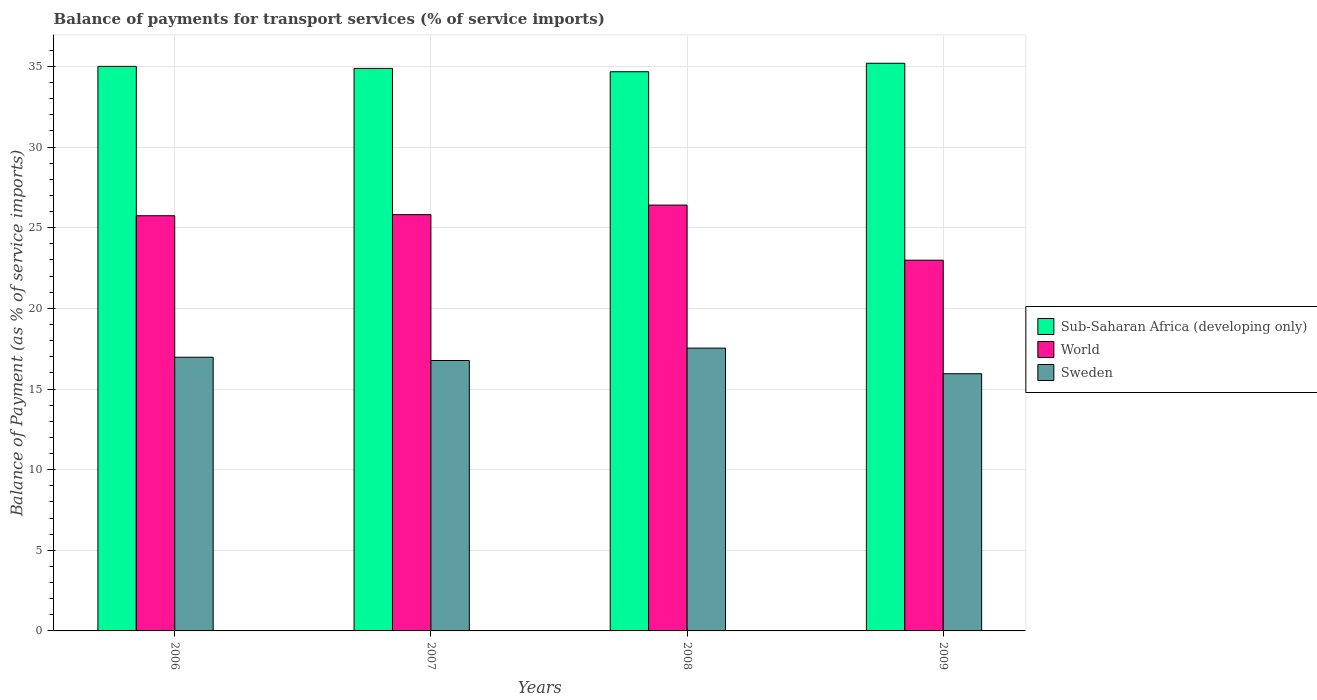How many different coloured bars are there?
Keep it short and to the point. 3. How many groups of bars are there?
Your answer should be compact. 4. What is the label of the 2nd group of bars from the left?
Your answer should be very brief. 2007. In how many cases, is the number of bars for a given year not equal to the number of legend labels?
Give a very brief answer. 0. What is the balance of payments for transport services in Sub-Saharan Africa (developing only) in 2008?
Ensure brevity in your answer.  34.67. Across all years, what is the maximum balance of payments for transport services in Sub-Saharan Africa (developing only)?
Your answer should be very brief. 35.2. Across all years, what is the minimum balance of payments for transport services in World?
Make the answer very short. 22.99. What is the total balance of payments for transport services in World in the graph?
Your answer should be compact. 100.95. What is the difference between the balance of payments for transport services in Sub-Saharan Africa (developing only) in 2006 and that in 2007?
Your answer should be very brief. 0.13. What is the difference between the balance of payments for transport services in World in 2008 and the balance of payments for transport services in Sub-Saharan Africa (developing only) in 2006?
Offer a terse response. -8.6. What is the average balance of payments for transport services in Sub-Saharan Africa (developing only) per year?
Your answer should be compact. 34.94. In the year 2008, what is the difference between the balance of payments for transport services in World and balance of payments for transport services in Sub-Saharan Africa (developing only)?
Your answer should be compact. -8.27. In how many years, is the balance of payments for transport services in World greater than 32 %?
Your answer should be very brief. 0. What is the ratio of the balance of payments for transport services in Sweden in 2006 to that in 2007?
Provide a succinct answer. 1.01. What is the difference between the highest and the second highest balance of payments for transport services in World?
Make the answer very short. 0.59. What is the difference between the highest and the lowest balance of payments for transport services in World?
Make the answer very short. 3.42. Is the sum of the balance of payments for transport services in World in 2006 and 2007 greater than the maximum balance of payments for transport services in Sub-Saharan Africa (developing only) across all years?
Offer a very short reply. Yes. What does the 1st bar from the left in 2008 represents?
Make the answer very short. Sub-Saharan Africa (developing only). What does the 1st bar from the right in 2007 represents?
Provide a short and direct response. Sweden. Is it the case that in every year, the sum of the balance of payments for transport services in Sub-Saharan Africa (developing only) and balance of payments for transport services in Sweden is greater than the balance of payments for transport services in World?
Provide a succinct answer. Yes. Where does the legend appear in the graph?
Your answer should be very brief. Center right. How are the legend labels stacked?
Ensure brevity in your answer.  Vertical. What is the title of the graph?
Your answer should be compact. Balance of payments for transport services (% of service imports). What is the label or title of the X-axis?
Ensure brevity in your answer.  Years. What is the label or title of the Y-axis?
Keep it short and to the point. Balance of Payment (as % of service imports). What is the Balance of Payment (as % of service imports) in Sub-Saharan Africa (developing only) in 2006?
Ensure brevity in your answer.  35. What is the Balance of Payment (as % of service imports) of World in 2006?
Provide a short and direct response. 25.74. What is the Balance of Payment (as % of service imports) in Sweden in 2006?
Ensure brevity in your answer.  16.97. What is the Balance of Payment (as % of service imports) in Sub-Saharan Africa (developing only) in 2007?
Offer a terse response. 34.88. What is the Balance of Payment (as % of service imports) in World in 2007?
Keep it short and to the point. 25.81. What is the Balance of Payment (as % of service imports) of Sweden in 2007?
Provide a short and direct response. 16.77. What is the Balance of Payment (as % of service imports) in Sub-Saharan Africa (developing only) in 2008?
Your answer should be very brief. 34.67. What is the Balance of Payment (as % of service imports) of World in 2008?
Provide a succinct answer. 26.4. What is the Balance of Payment (as % of service imports) of Sweden in 2008?
Your answer should be compact. 17.54. What is the Balance of Payment (as % of service imports) of Sub-Saharan Africa (developing only) in 2009?
Your answer should be very brief. 35.2. What is the Balance of Payment (as % of service imports) of World in 2009?
Make the answer very short. 22.99. What is the Balance of Payment (as % of service imports) of Sweden in 2009?
Ensure brevity in your answer.  15.95. Across all years, what is the maximum Balance of Payment (as % of service imports) in Sub-Saharan Africa (developing only)?
Your answer should be compact. 35.2. Across all years, what is the maximum Balance of Payment (as % of service imports) in World?
Give a very brief answer. 26.4. Across all years, what is the maximum Balance of Payment (as % of service imports) in Sweden?
Make the answer very short. 17.54. Across all years, what is the minimum Balance of Payment (as % of service imports) of Sub-Saharan Africa (developing only)?
Offer a terse response. 34.67. Across all years, what is the minimum Balance of Payment (as % of service imports) in World?
Your answer should be compact. 22.99. Across all years, what is the minimum Balance of Payment (as % of service imports) of Sweden?
Keep it short and to the point. 15.95. What is the total Balance of Payment (as % of service imports) of Sub-Saharan Africa (developing only) in the graph?
Offer a terse response. 139.75. What is the total Balance of Payment (as % of service imports) in World in the graph?
Give a very brief answer. 100.95. What is the total Balance of Payment (as % of service imports) of Sweden in the graph?
Ensure brevity in your answer.  67.22. What is the difference between the Balance of Payment (as % of service imports) in Sub-Saharan Africa (developing only) in 2006 and that in 2007?
Offer a terse response. 0.13. What is the difference between the Balance of Payment (as % of service imports) of World in 2006 and that in 2007?
Your answer should be compact. -0.07. What is the difference between the Balance of Payment (as % of service imports) in Sweden in 2006 and that in 2007?
Offer a very short reply. 0.2. What is the difference between the Balance of Payment (as % of service imports) in Sub-Saharan Africa (developing only) in 2006 and that in 2008?
Ensure brevity in your answer.  0.33. What is the difference between the Balance of Payment (as % of service imports) of World in 2006 and that in 2008?
Make the answer very short. -0.66. What is the difference between the Balance of Payment (as % of service imports) of Sweden in 2006 and that in 2008?
Provide a succinct answer. -0.56. What is the difference between the Balance of Payment (as % of service imports) in Sub-Saharan Africa (developing only) in 2006 and that in 2009?
Ensure brevity in your answer.  -0.19. What is the difference between the Balance of Payment (as % of service imports) of World in 2006 and that in 2009?
Provide a succinct answer. 2.76. What is the difference between the Balance of Payment (as % of service imports) in Sweden in 2006 and that in 2009?
Keep it short and to the point. 1.02. What is the difference between the Balance of Payment (as % of service imports) in Sub-Saharan Africa (developing only) in 2007 and that in 2008?
Offer a very short reply. 0.21. What is the difference between the Balance of Payment (as % of service imports) of World in 2007 and that in 2008?
Your answer should be compact. -0.59. What is the difference between the Balance of Payment (as % of service imports) of Sweden in 2007 and that in 2008?
Keep it short and to the point. -0.77. What is the difference between the Balance of Payment (as % of service imports) in Sub-Saharan Africa (developing only) in 2007 and that in 2009?
Offer a terse response. -0.32. What is the difference between the Balance of Payment (as % of service imports) in World in 2007 and that in 2009?
Keep it short and to the point. 2.83. What is the difference between the Balance of Payment (as % of service imports) of Sweden in 2007 and that in 2009?
Ensure brevity in your answer.  0.82. What is the difference between the Balance of Payment (as % of service imports) of Sub-Saharan Africa (developing only) in 2008 and that in 2009?
Ensure brevity in your answer.  -0.53. What is the difference between the Balance of Payment (as % of service imports) in World in 2008 and that in 2009?
Your answer should be very brief. 3.42. What is the difference between the Balance of Payment (as % of service imports) of Sweden in 2008 and that in 2009?
Keep it short and to the point. 1.59. What is the difference between the Balance of Payment (as % of service imports) in Sub-Saharan Africa (developing only) in 2006 and the Balance of Payment (as % of service imports) in World in 2007?
Ensure brevity in your answer.  9.19. What is the difference between the Balance of Payment (as % of service imports) of Sub-Saharan Africa (developing only) in 2006 and the Balance of Payment (as % of service imports) of Sweden in 2007?
Provide a succinct answer. 18.24. What is the difference between the Balance of Payment (as % of service imports) in World in 2006 and the Balance of Payment (as % of service imports) in Sweden in 2007?
Give a very brief answer. 8.98. What is the difference between the Balance of Payment (as % of service imports) in Sub-Saharan Africa (developing only) in 2006 and the Balance of Payment (as % of service imports) in World in 2008?
Ensure brevity in your answer.  8.6. What is the difference between the Balance of Payment (as % of service imports) of Sub-Saharan Africa (developing only) in 2006 and the Balance of Payment (as % of service imports) of Sweden in 2008?
Provide a succinct answer. 17.47. What is the difference between the Balance of Payment (as % of service imports) of World in 2006 and the Balance of Payment (as % of service imports) of Sweden in 2008?
Offer a very short reply. 8.21. What is the difference between the Balance of Payment (as % of service imports) of Sub-Saharan Africa (developing only) in 2006 and the Balance of Payment (as % of service imports) of World in 2009?
Give a very brief answer. 12.02. What is the difference between the Balance of Payment (as % of service imports) of Sub-Saharan Africa (developing only) in 2006 and the Balance of Payment (as % of service imports) of Sweden in 2009?
Offer a terse response. 19.06. What is the difference between the Balance of Payment (as % of service imports) in World in 2006 and the Balance of Payment (as % of service imports) in Sweden in 2009?
Offer a very short reply. 9.8. What is the difference between the Balance of Payment (as % of service imports) of Sub-Saharan Africa (developing only) in 2007 and the Balance of Payment (as % of service imports) of World in 2008?
Provide a short and direct response. 8.47. What is the difference between the Balance of Payment (as % of service imports) of Sub-Saharan Africa (developing only) in 2007 and the Balance of Payment (as % of service imports) of Sweden in 2008?
Ensure brevity in your answer.  17.34. What is the difference between the Balance of Payment (as % of service imports) of World in 2007 and the Balance of Payment (as % of service imports) of Sweden in 2008?
Your answer should be very brief. 8.28. What is the difference between the Balance of Payment (as % of service imports) of Sub-Saharan Africa (developing only) in 2007 and the Balance of Payment (as % of service imports) of World in 2009?
Offer a very short reply. 11.89. What is the difference between the Balance of Payment (as % of service imports) in Sub-Saharan Africa (developing only) in 2007 and the Balance of Payment (as % of service imports) in Sweden in 2009?
Your response must be concise. 18.93. What is the difference between the Balance of Payment (as % of service imports) of World in 2007 and the Balance of Payment (as % of service imports) of Sweden in 2009?
Ensure brevity in your answer.  9.86. What is the difference between the Balance of Payment (as % of service imports) in Sub-Saharan Africa (developing only) in 2008 and the Balance of Payment (as % of service imports) in World in 2009?
Keep it short and to the point. 11.69. What is the difference between the Balance of Payment (as % of service imports) of Sub-Saharan Africa (developing only) in 2008 and the Balance of Payment (as % of service imports) of Sweden in 2009?
Give a very brief answer. 18.72. What is the difference between the Balance of Payment (as % of service imports) of World in 2008 and the Balance of Payment (as % of service imports) of Sweden in 2009?
Offer a terse response. 10.46. What is the average Balance of Payment (as % of service imports) of Sub-Saharan Africa (developing only) per year?
Offer a very short reply. 34.94. What is the average Balance of Payment (as % of service imports) in World per year?
Give a very brief answer. 25.24. What is the average Balance of Payment (as % of service imports) in Sweden per year?
Make the answer very short. 16.8. In the year 2006, what is the difference between the Balance of Payment (as % of service imports) in Sub-Saharan Africa (developing only) and Balance of Payment (as % of service imports) in World?
Ensure brevity in your answer.  9.26. In the year 2006, what is the difference between the Balance of Payment (as % of service imports) of Sub-Saharan Africa (developing only) and Balance of Payment (as % of service imports) of Sweden?
Give a very brief answer. 18.03. In the year 2006, what is the difference between the Balance of Payment (as % of service imports) of World and Balance of Payment (as % of service imports) of Sweden?
Your answer should be compact. 8.77. In the year 2007, what is the difference between the Balance of Payment (as % of service imports) of Sub-Saharan Africa (developing only) and Balance of Payment (as % of service imports) of World?
Ensure brevity in your answer.  9.07. In the year 2007, what is the difference between the Balance of Payment (as % of service imports) of Sub-Saharan Africa (developing only) and Balance of Payment (as % of service imports) of Sweden?
Make the answer very short. 18.11. In the year 2007, what is the difference between the Balance of Payment (as % of service imports) in World and Balance of Payment (as % of service imports) in Sweden?
Make the answer very short. 9.04. In the year 2008, what is the difference between the Balance of Payment (as % of service imports) in Sub-Saharan Africa (developing only) and Balance of Payment (as % of service imports) in World?
Provide a short and direct response. 8.27. In the year 2008, what is the difference between the Balance of Payment (as % of service imports) in Sub-Saharan Africa (developing only) and Balance of Payment (as % of service imports) in Sweden?
Offer a terse response. 17.14. In the year 2008, what is the difference between the Balance of Payment (as % of service imports) of World and Balance of Payment (as % of service imports) of Sweden?
Make the answer very short. 8.87. In the year 2009, what is the difference between the Balance of Payment (as % of service imports) of Sub-Saharan Africa (developing only) and Balance of Payment (as % of service imports) of World?
Offer a terse response. 12.21. In the year 2009, what is the difference between the Balance of Payment (as % of service imports) in Sub-Saharan Africa (developing only) and Balance of Payment (as % of service imports) in Sweden?
Your response must be concise. 19.25. In the year 2009, what is the difference between the Balance of Payment (as % of service imports) in World and Balance of Payment (as % of service imports) in Sweden?
Provide a short and direct response. 7.04. What is the ratio of the Balance of Payment (as % of service imports) in Sub-Saharan Africa (developing only) in 2006 to that in 2007?
Provide a short and direct response. 1. What is the ratio of the Balance of Payment (as % of service imports) in Sweden in 2006 to that in 2007?
Provide a short and direct response. 1.01. What is the ratio of the Balance of Payment (as % of service imports) of Sub-Saharan Africa (developing only) in 2006 to that in 2008?
Ensure brevity in your answer.  1.01. What is the ratio of the Balance of Payment (as % of service imports) of Sweden in 2006 to that in 2008?
Provide a succinct answer. 0.97. What is the ratio of the Balance of Payment (as % of service imports) of World in 2006 to that in 2009?
Your answer should be compact. 1.12. What is the ratio of the Balance of Payment (as % of service imports) in Sweden in 2006 to that in 2009?
Your response must be concise. 1.06. What is the ratio of the Balance of Payment (as % of service imports) of Sub-Saharan Africa (developing only) in 2007 to that in 2008?
Your answer should be very brief. 1.01. What is the ratio of the Balance of Payment (as % of service imports) of World in 2007 to that in 2008?
Give a very brief answer. 0.98. What is the ratio of the Balance of Payment (as % of service imports) in Sweden in 2007 to that in 2008?
Offer a terse response. 0.96. What is the ratio of the Balance of Payment (as % of service imports) in Sub-Saharan Africa (developing only) in 2007 to that in 2009?
Ensure brevity in your answer.  0.99. What is the ratio of the Balance of Payment (as % of service imports) in World in 2007 to that in 2009?
Keep it short and to the point. 1.12. What is the ratio of the Balance of Payment (as % of service imports) in Sweden in 2007 to that in 2009?
Offer a terse response. 1.05. What is the ratio of the Balance of Payment (as % of service imports) of Sub-Saharan Africa (developing only) in 2008 to that in 2009?
Provide a succinct answer. 0.99. What is the ratio of the Balance of Payment (as % of service imports) in World in 2008 to that in 2009?
Your response must be concise. 1.15. What is the ratio of the Balance of Payment (as % of service imports) in Sweden in 2008 to that in 2009?
Your answer should be compact. 1.1. What is the difference between the highest and the second highest Balance of Payment (as % of service imports) in Sub-Saharan Africa (developing only)?
Make the answer very short. 0.19. What is the difference between the highest and the second highest Balance of Payment (as % of service imports) of World?
Offer a terse response. 0.59. What is the difference between the highest and the second highest Balance of Payment (as % of service imports) of Sweden?
Offer a terse response. 0.56. What is the difference between the highest and the lowest Balance of Payment (as % of service imports) in Sub-Saharan Africa (developing only)?
Your answer should be compact. 0.53. What is the difference between the highest and the lowest Balance of Payment (as % of service imports) of World?
Your response must be concise. 3.42. What is the difference between the highest and the lowest Balance of Payment (as % of service imports) in Sweden?
Offer a very short reply. 1.59. 